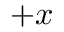Convert formula to latex. <formula><loc_0><loc_0><loc_500><loc_500>+ x</formula> 